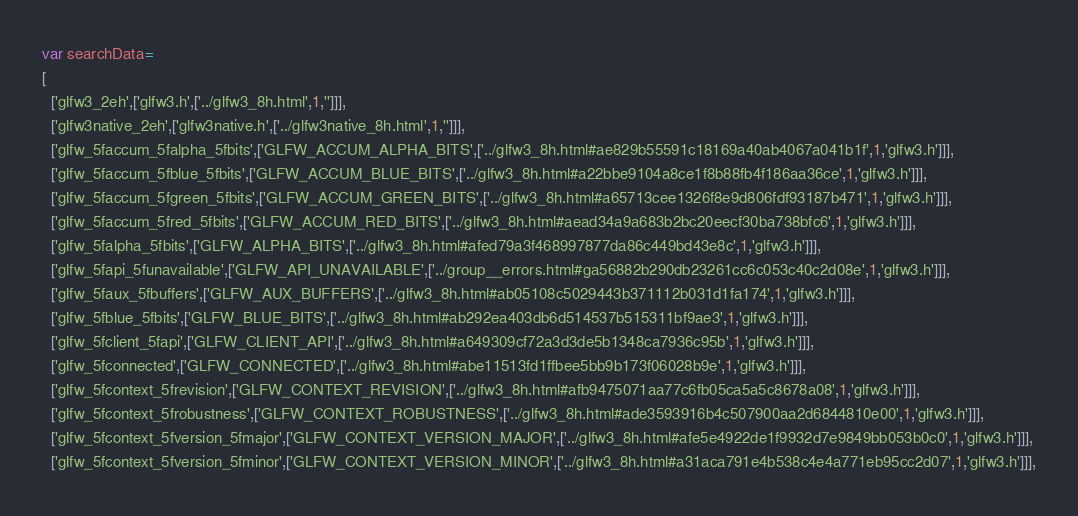Convert code to text. <code><loc_0><loc_0><loc_500><loc_500><_JavaScript_>var searchData=
[
  ['glfw3_2eh',['glfw3.h',['../glfw3_8h.html',1,'']]],
  ['glfw3native_2eh',['glfw3native.h',['../glfw3native_8h.html',1,'']]],
  ['glfw_5faccum_5falpha_5fbits',['GLFW_ACCUM_ALPHA_BITS',['../glfw3_8h.html#ae829b55591c18169a40ab4067a041b1f',1,'glfw3.h']]],
  ['glfw_5faccum_5fblue_5fbits',['GLFW_ACCUM_BLUE_BITS',['../glfw3_8h.html#a22bbe9104a8ce1f8b88fb4f186aa36ce',1,'glfw3.h']]],
  ['glfw_5faccum_5fgreen_5fbits',['GLFW_ACCUM_GREEN_BITS',['../glfw3_8h.html#a65713cee1326f8e9d806fdf93187b471',1,'glfw3.h']]],
  ['glfw_5faccum_5fred_5fbits',['GLFW_ACCUM_RED_BITS',['../glfw3_8h.html#aead34a9a683b2bc20eecf30ba738bfc6',1,'glfw3.h']]],
  ['glfw_5falpha_5fbits',['GLFW_ALPHA_BITS',['../glfw3_8h.html#afed79a3f468997877da86c449bd43e8c',1,'glfw3.h']]],
  ['glfw_5fapi_5funavailable',['GLFW_API_UNAVAILABLE',['../group__errors.html#ga56882b290db23261cc6c053c40c2d08e',1,'glfw3.h']]],
  ['glfw_5faux_5fbuffers',['GLFW_AUX_BUFFERS',['../glfw3_8h.html#ab05108c5029443b371112b031d1fa174',1,'glfw3.h']]],
  ['glfw_5fblue_5fbits',['GLFW_BLUE_BITS',['../glfw3_8h.html#ab292ea403db6d514537b515311bf9ae3',1,'glfw3.h']]],
  ['glfw_5fclient_5fapi',['GLFW_CLIENT_API',['../glfw3_8h.html#a649309cf72a3d3de5b1348ca7936c95b',1,'glfw3.h']]],
  ['glfw_5fconnected',['GLFW_CONNECTED',['../glfw3_8h.html#abe11513fd1ffbee5bb9b173f06028b9e',1,'glfw3.h']]],
  ['glfw_5fcontext_5frevision',['GLFW_CONTEXT_REVISION',['../glfw3_8h.html#afb9475071aa77c6fb05ca5a5c8678a08',1,'glfw3.h']]],
  ['glfw_5fcontext_5frobustness',['GLFW_CONTEXT_ROBUSTNESS',['../glfw3_8h.html#ade3593916b4c507900aa2d6844810e00',1,'glfw3.h']]],
  ['glfw_5fcontext_5fversion_5fmajor',['GLFW_CONTEXT_VERSION_MAJOR',['../glfw3_8h.html#afe5e4922de1f9932d7e9849bb053b0c0',1,'glfw3.h']]],
  ['glfw_5fcontext_5fversion_5fminor',['GLFW_CONTEXT_VERSION_MINOR',['../glfw3_8h.html#a31aca791e4b538c4e4a771eb95cc2d07',1,'glfw3.h']]],</code> 